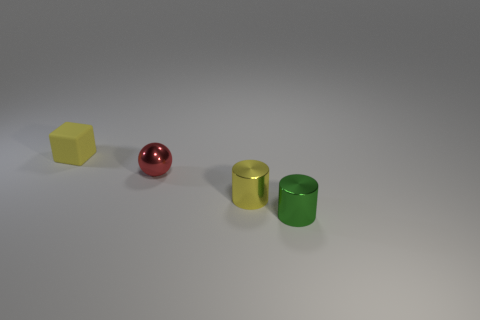Can you describe the lighting in the scene? The scene is evenly lit with a soft, diffused light source that minimizes harsh shadows and creates a calm, muted atmosphere. 